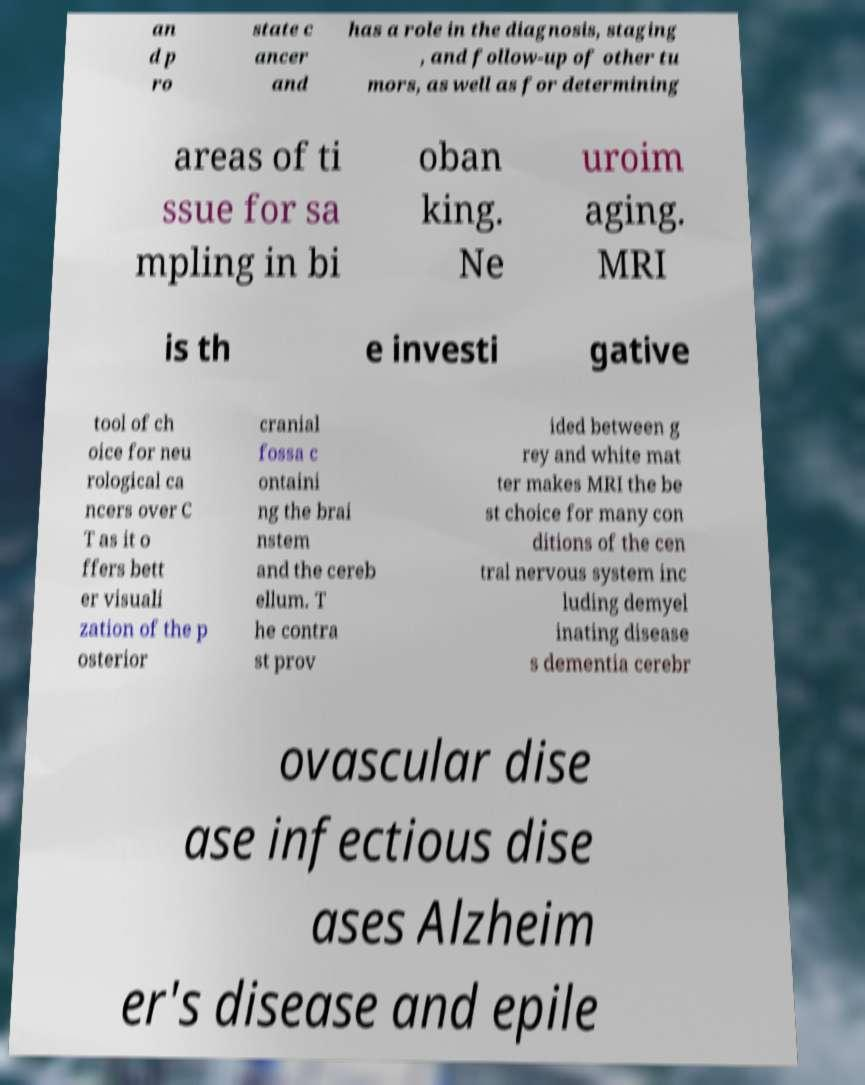There's text embedded in this image that I need extracted. Can you transcribe it verbatim? an d p ro state c ancer and has a role in the diagnosis, staging , and follow-up of other tu mors, as well as for determining areas of ti ssue for sa mpling in bi oban king. Ne uroim aging. MRI is th e investi gative tool of ch oice for neu rological ca ncers over C T as it o ffers bett er visuali zation of the p osterior cranial fossa c ontaini ng the brai nstem and the cereb ellum. T he contra st prov ided between g rey and white mat ter makes MRI the be st choice for many con ditions of the cen tral nervous system inc luding demyel inating disease s dementia cerebr ovascular dise ase infectious dise ases Alzheim er's disease and epile 